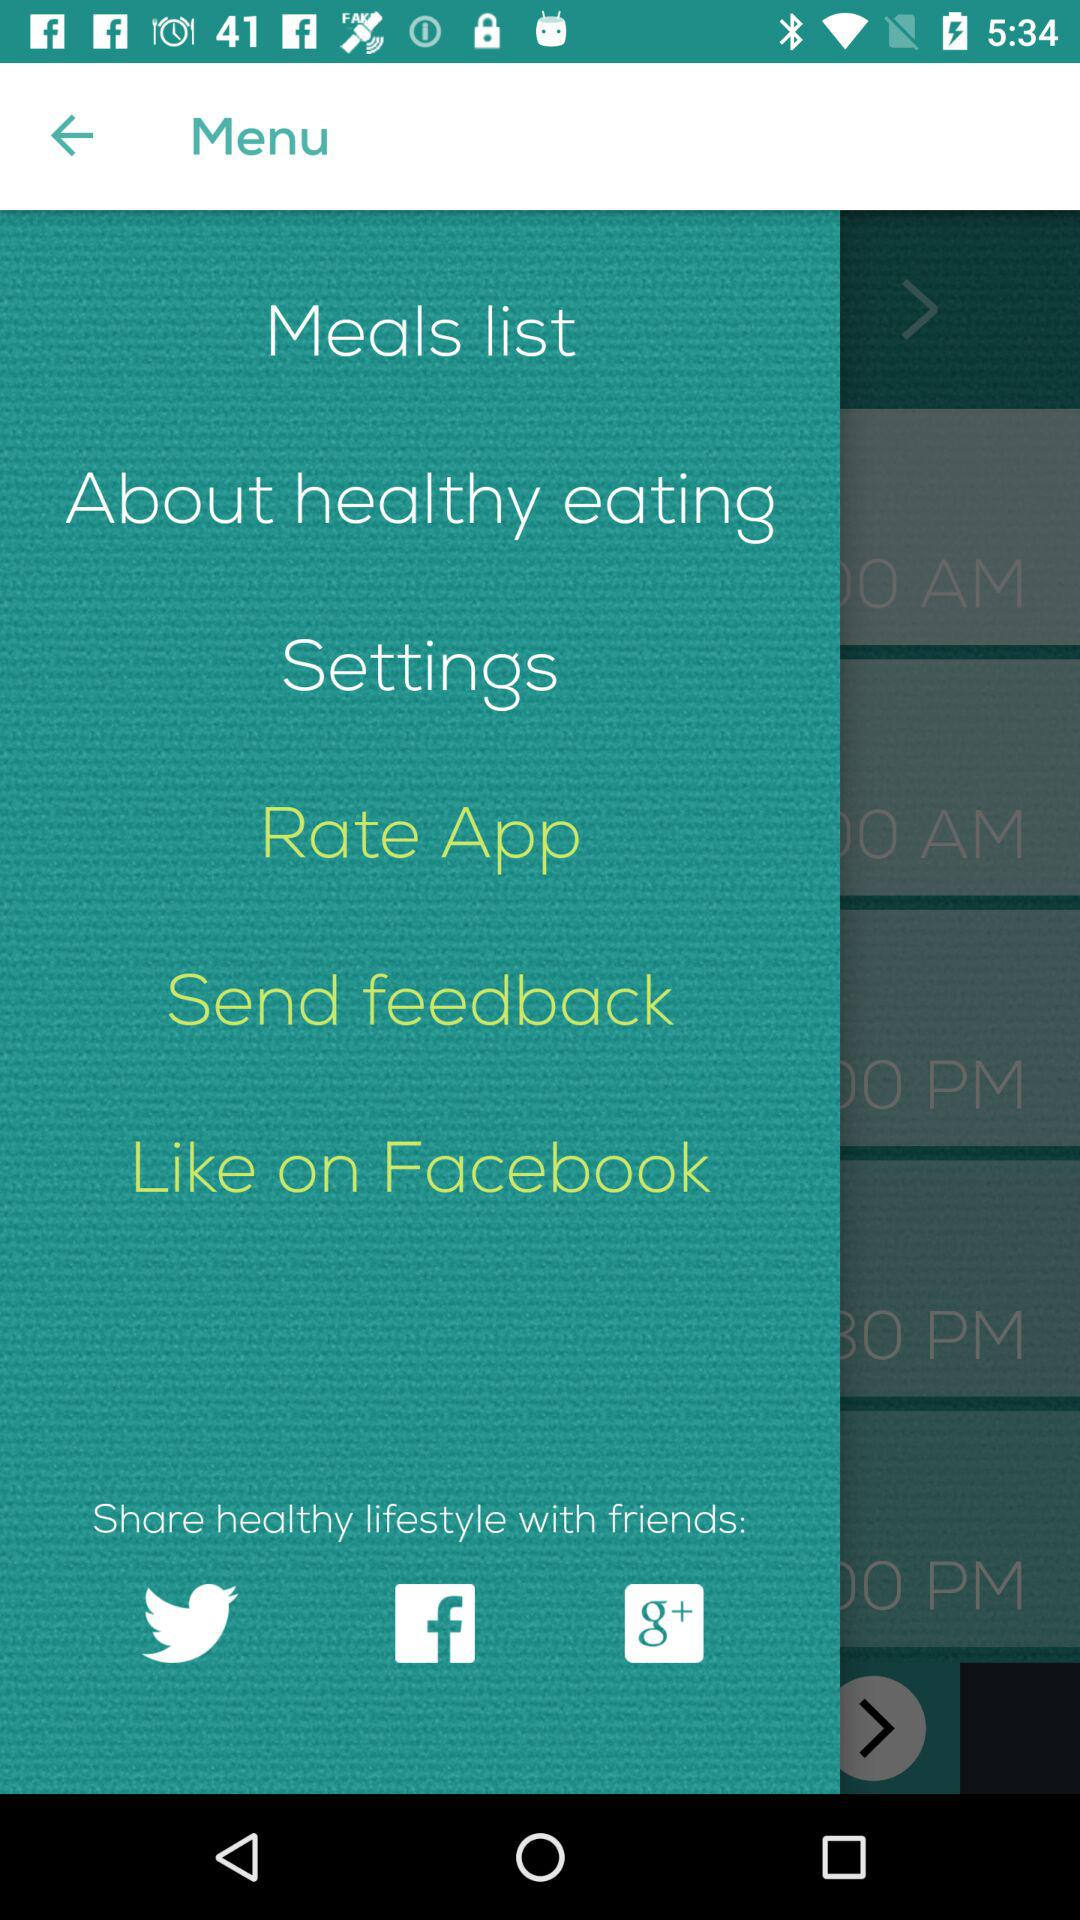What accounts can be used to share healthy lifestyles with friends? The accounts that can be used to share are "Twitter", "Facebook" and "Google+". 